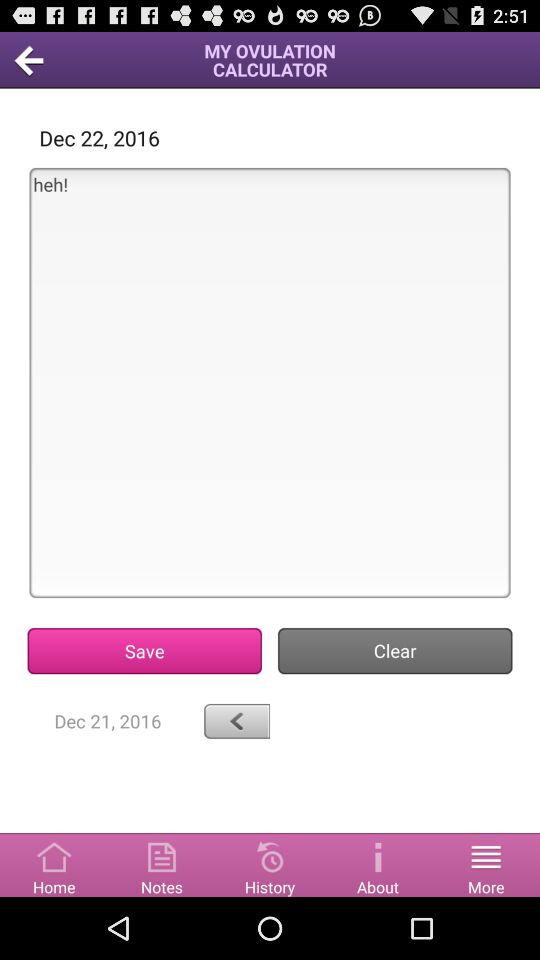How many days are there between the first and second dates?
Answer the question using a single word or phrase. 1 